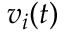<formula> <loc_0><loc_0><loc_500><loc_500>v _ { i } ( t )</formula> 